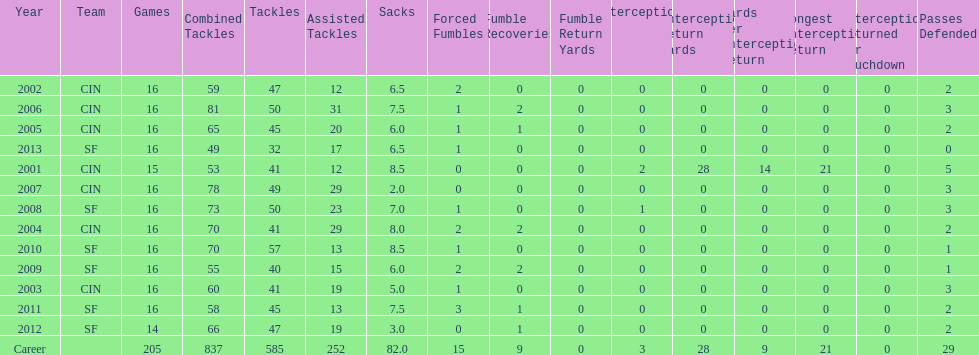What is the total number of sacks smith has made? 82.0. 